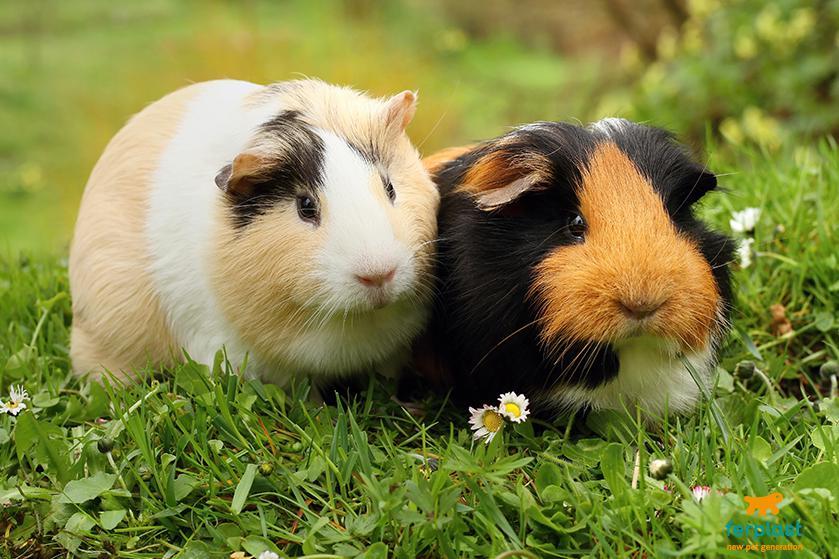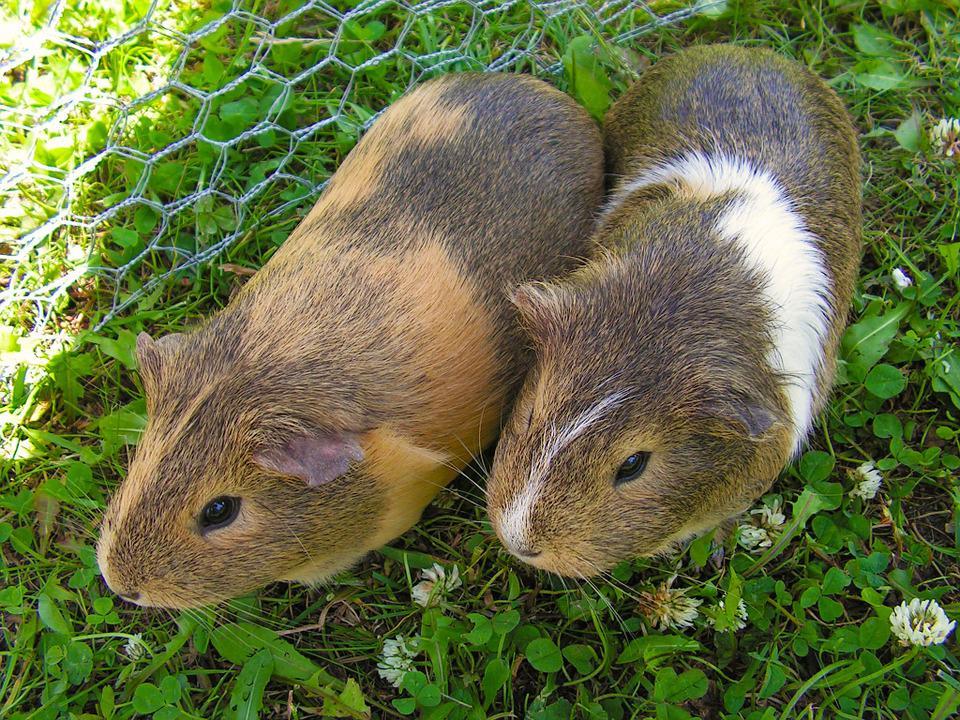The first image is the image on the left, the second image is the image on the right. For the images shown, is this caption "Two rodents are sitting together in the grass in each of the images." true? Answer yes or no. Yes. The first image is the image on the left, the second image is the image on the right. For the images displayed, is the sentence "Each image shows exactly one side-by-side pair of guinea pigs posed outdoors on green ground." factually correct? Answer yes or no. Yes. 